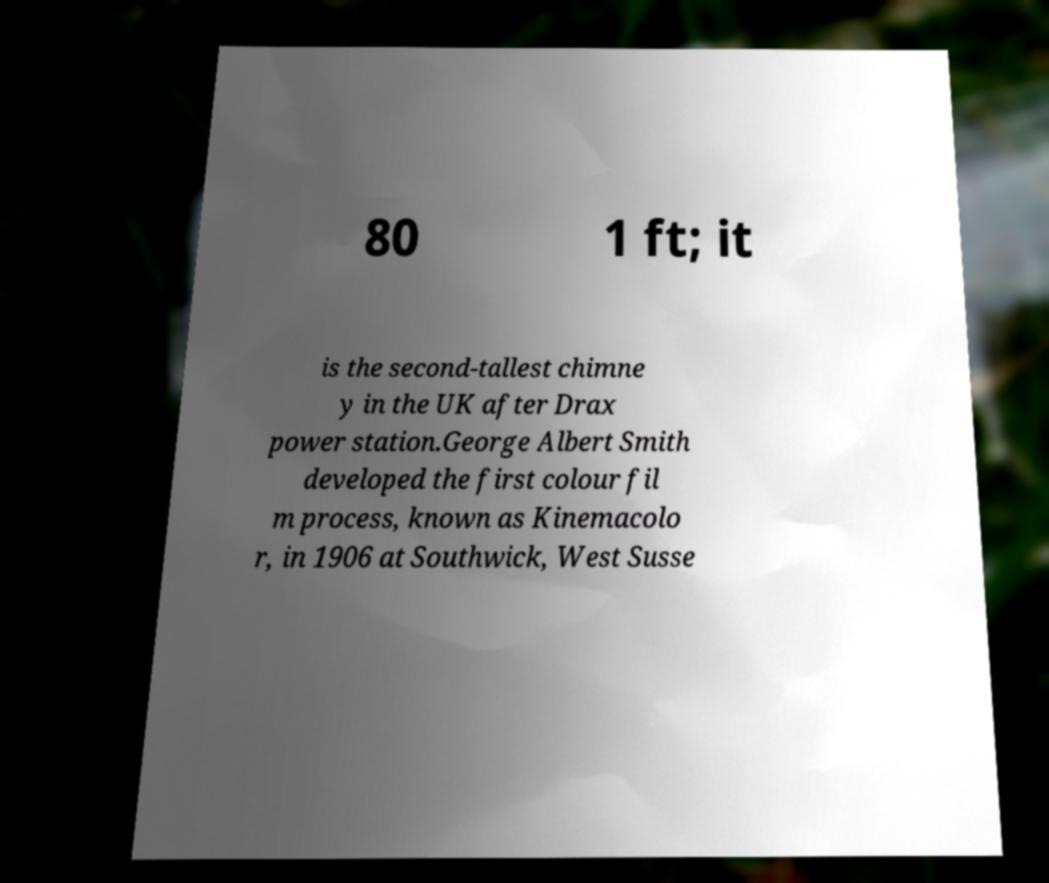Could you assist in decoding the text presented in this image and type it out clearly? 80 1 ft; it is the second-tallest chimne y in the UK after Drax power station.George Albert Smith developed the first colour fil m process, known as Kinemacolo r, in 1906 at Southwick, West Susse 